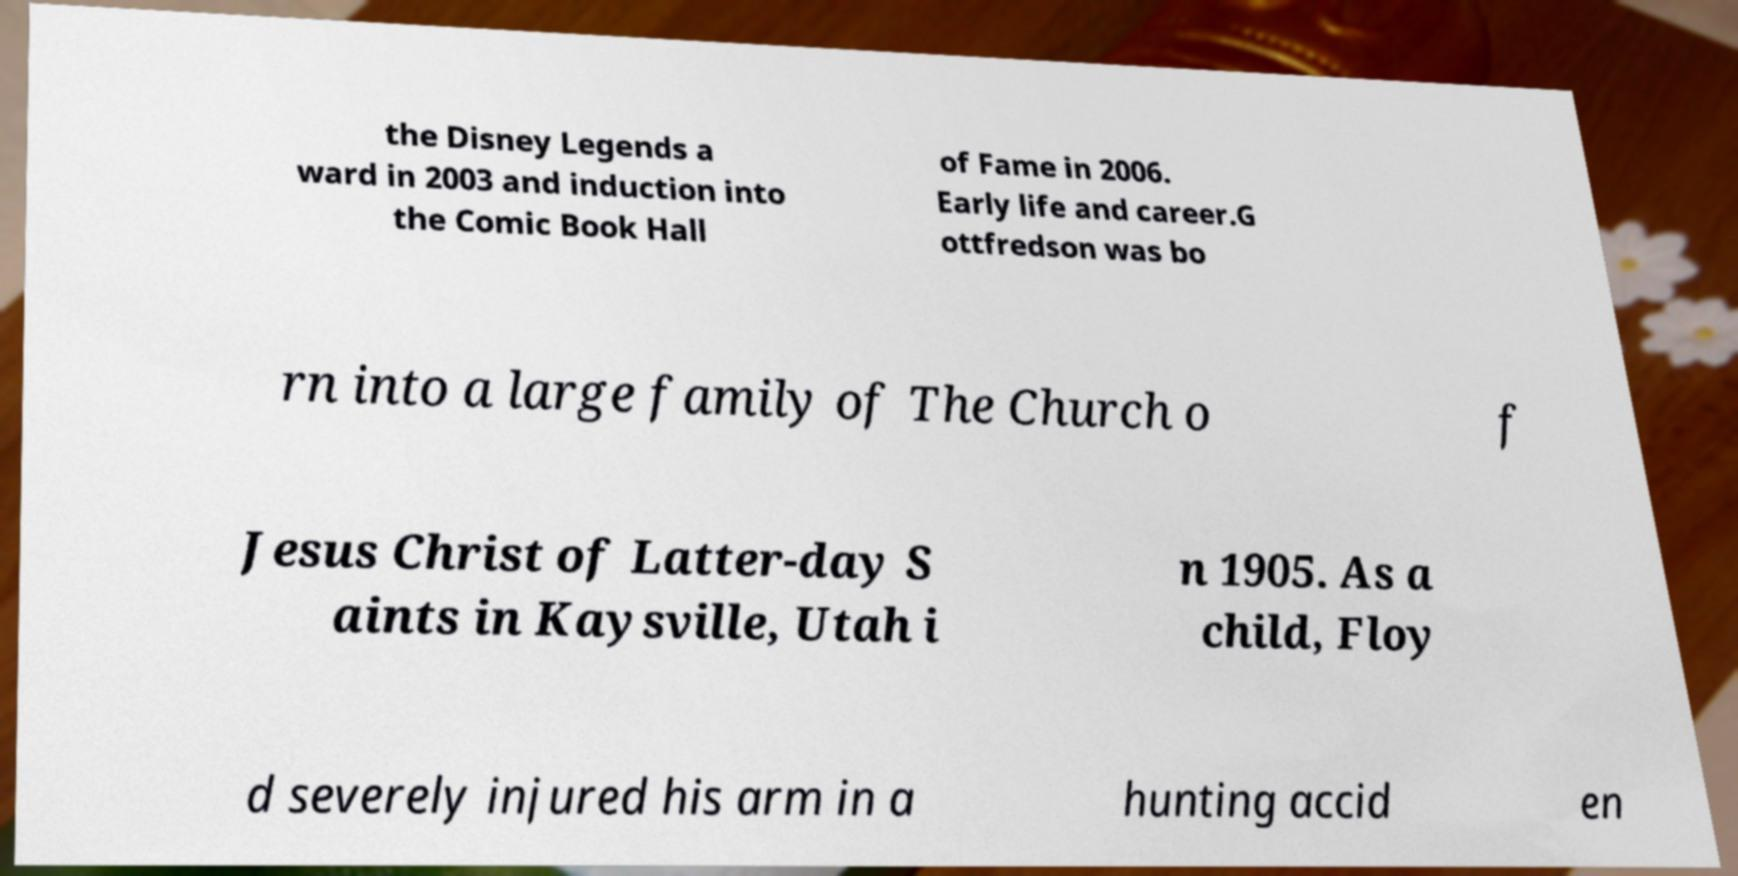Could you assist in decoding the text presented in this image and type it out clearly? the Disney Legends a ward in 2003 and induction into the Comic Book Hall of Fame in 2006. Early life and career.G ottfredson was bo rn into a large family of The Church o f Jesus Christ of Latter-day S aints in Kaysville, Utah i n 1905. As a child, Floy d severely injured his arm in a hunting accid en 